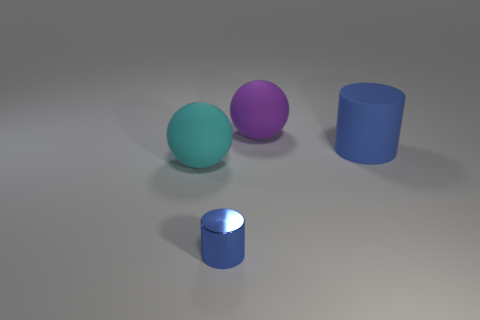How many matte cylinders have the same color as the small object?
Your response must be concise. 1. Are there more big matte balls in front of the purple matte ball than blue things on the right side of the big blue object?
Make the answer very short. Yes. There is a thing that is both in front of the large blue matte cylinder and on the right side of the cyan ball; what material is it?
Provide a short and direct response. Metal. Is the shape of the big cyan rubber object the same as the big purple matte thing?
Keep it short and to the point. Yes. Is there any other thing that has the same size as the blue metallic object?
Offer a very short reply. No. What number of tiny objects are on the left side of the shiny object?
Make the answer very short. 0. Does the ball that is behind the cyan sphere have the same size as the cyan rubber thing?
Provide a short and direct response. Yes. There is another big matte thing that is the same shape as the cyan thing; what is its color?
Provide a succinct answer. Purple. What is the shape of the blue thing on the right side of the purple ball?
Give a very brief answer. Cylinder. What number of small things are the same shape as the big cyan rubber object?
Provide a succinct answer. 0. 